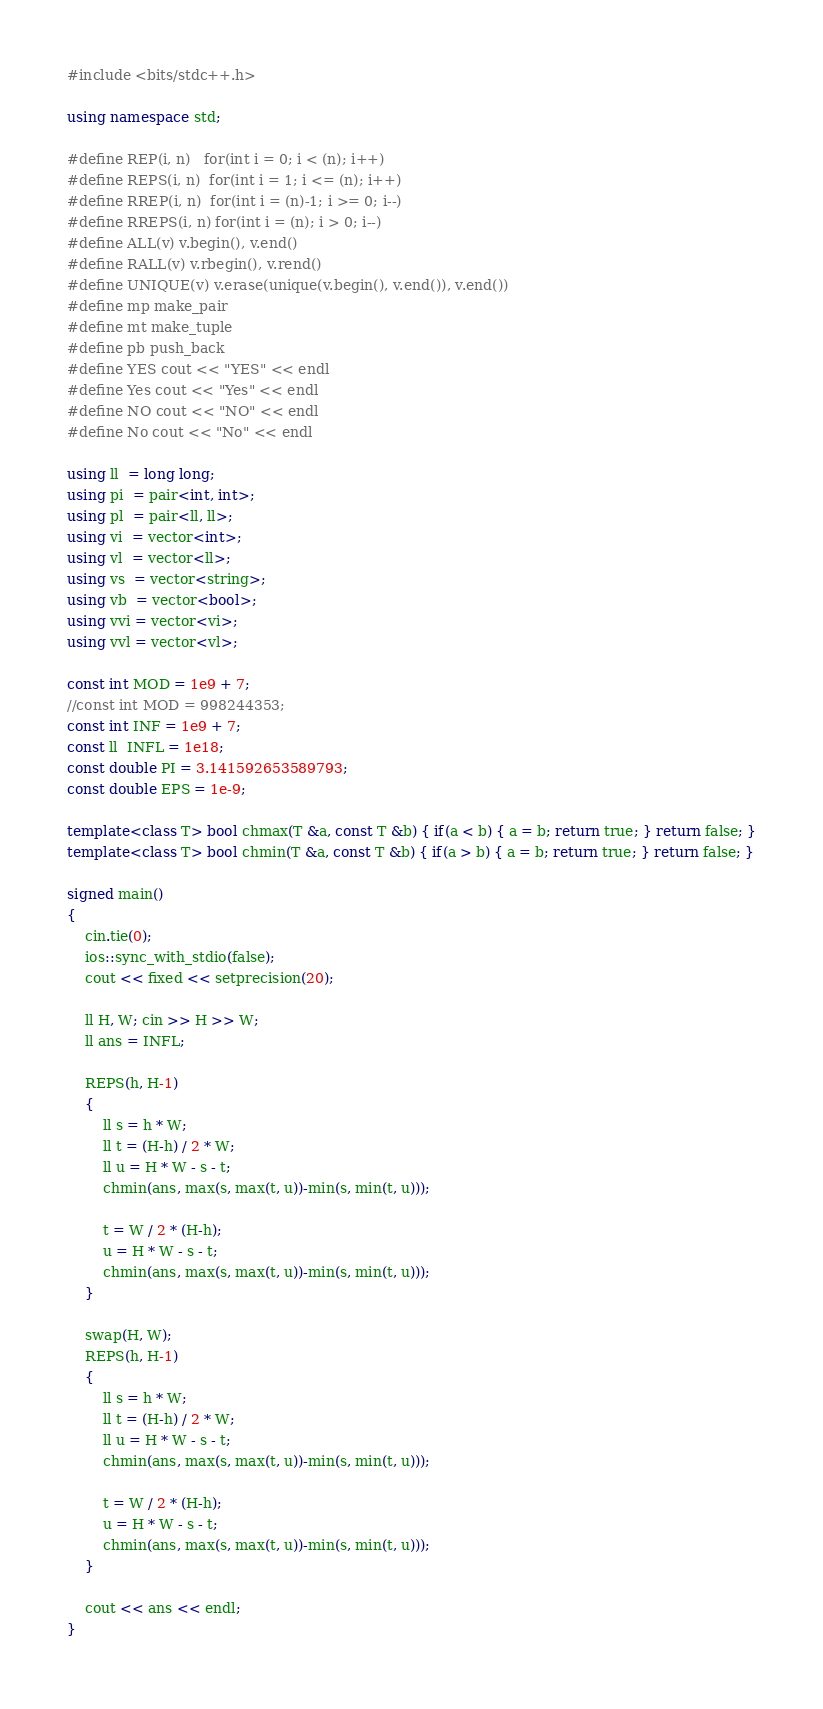<code> <loc_0><loc_0><loc_500><loc_500><_C++_>#include <bits/stdc++.h>

using namespace std;

#define REP(i, n)   for(int i = 0; i < (n); i++)
#define REPS(i, n)  for(int i = 1; i <= (n); i++)
#define RREP(i, n)  for(int i = (n)-1; i >= 0; i--)
#define RREPS(i, n) for(int i = (n); i > 0; i--)
#define ALL(v) v.begin(), v.end()
#define RALL(v) v.rbegin(), v.rend()
#define UNIQUE(v) v.erase(unique(v.begin(), v.end()), v.end())
#define mp make_pair
#define mt make_tuple
#define pb push_back
#define YES cout << "YES" << endl
#define Yes cout << "Yes" << endl
#define NO cout << "NO" << endl
#define No cout << "No" << endl

using ll  = long long;
using pi  = pair<int, int>;
using pl  = pair<ll, ll>;
using vi  = vector<int>;
using vl  = vector<ll>;
using vs  = vector<string>;
using vb  = vector<bool>;
using vvi = vector<vi>;
using vvl = vector<vl>;

const int MOD = 1e9 + 7;
//const int MOD = 998244353;
const int INF = 1e9 + 7;
const ll  INFL = 1e18;
const double PI = 3.141592653589793;
const double EPS = 1e-9;

template<class T> bool chmax(T &a, const T &b) { if(a < b) { a = b; return true; } return false; }
template<class T> bool chmin(T &a, const T &b) { if(a > b) { a = b; return true; } return false; }

signed main()
{
    cin.tie(0);
    ios::sync_with_stdio(false);
    cout << fixed << setprecision(20);

    ll H, W; cin >> H >> W;
    ll ans = INFL;

    REPS(h, H-1)
    {
        ll s = h * W;
        ll t = (H-h) / 2 * W;
        ll u = H * W - s - t;
        chmin(ans, max(s, max(t, u))-min(s, min(t, u)));

        t = W / 2 * (H-h);
        u = H * W - s - t;
        chmin(ans, max(s, max(t, u))-min(s, min(t, u)));
    }

    swap(H, W);
    REPS(h, H-1)
    {
        ll s = h * W;
        ll t = (H-h) / 2 * W;
        ll u = H * W - s - t;
        chmin(ans, max(s, max(t, u))-min(s, min(t, u)));

        t = W / 2 * (H-h);
        u = H * W - s - t;
        chmin(ans, max(s, max(t, u))-min(s, min(t, u)));
    }

    cout << ans << endl;
}</code> 